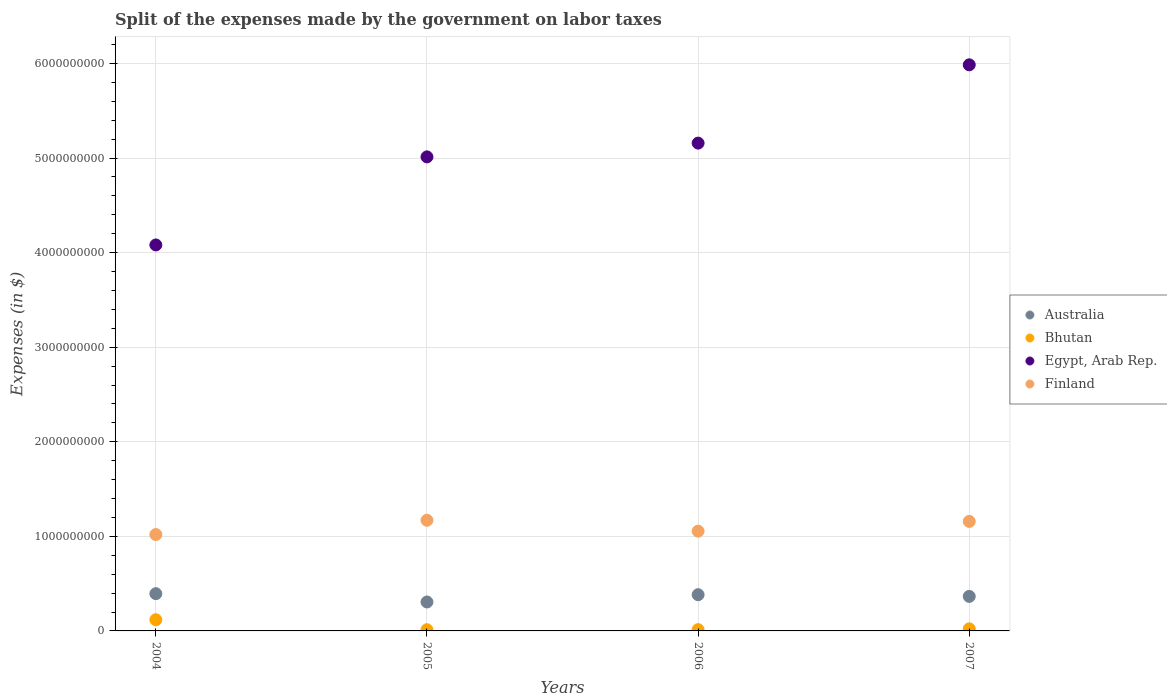What is the expenses made by the government on labor taxes in Finland in 2005?
Offer a very short reply. 1.17e+09. Across all years, what is the maximum expenses made by the government on labor taxes in Australia?
Provide a succinct answer. 3.94e+08. Across all years, what is the minimum expenses made by the government on labor taxes in Finland?
Ensure brevity in your answer.  1.02e+09. What is the total expenses made by the government on labor taxes in Bhutan in the graph?
Keep it short and to the point. 1.66e+08. What is the difference between the expenses made by the government on labor taxes in Bhutan in 2005 and that in 2006?
Make the answer very short. -6.82e+05. What is the difference between the expenses made by the government on labor taxes in Egypt, Arab Rep. in 2004 and the expenses made by the government on labor taxes in Finland in 2005?
Your answer should be compact. 2.91e+09. What is the average expenses made by the government on labor taxes in Egypt, Arab Rep. per year?
Your response must be concise. 5.06e+09. In the year 2007, what is the difference between the expenses made by the government on labor taxes in Bhutan and expenses made by the government on labor taxes in Australia?
Give a very brief answer. -3.43e+08. What is the ratio of the expenses made by the government on labor taxes in Australia in 2004 to that in 2005?
Your response must be concise. 1.29. Is the expenses made by the government on labor taxes in Australia in 2004 less than that in 2005?
Offer a very short reply. No. Is the difference between the expenses made by the government on labor taxes in Bhutan in 2004 and 2007 greater than the difference between the expenses made by the government on labor taxes in Australia in 2004 and 2007?
Your answer should be very brief. Yes. What is the difference between the highest and the lowest expenses made by the government on labor taxes in Australia?
Your answer should be compact. 8.80e+07. In how many years, is the expenses made by the government on labor taxes in Finland greater than the average expenses made by the government on labor taxes in Finland taken over all years?
Your response must be concise. 2. Is it the case that in every year, the sum of the expenses made by the government on labor taxes in Finland and expenses made by the government on labor taxes in Bhutan  is greater than the sum of expenses made by the government on labor taxes in Australia and expenses made by the government on labor taxes in Egypt, Arab Rep.?
Offer a very short reply. Yes. Is the expenses made by the government on labor taxes in Bhutan strictly greater than the expenses made by the government on labor taxes in Australia over the years?
Give a very brief answer. No. Is the expenses made by the government on labor taxes in Australia strictly less than the expenses made by the government on labor taxes in Bhutan over the years?
Your answer should be compact. No. How many years are there in the graph?
Your answer should be very brief. 4. What is the difference between two consecutive major ticks on the Y-axis?
Your response must be concise. 1.00e+09. Are the values on the major ticks of Y-axis written in scientific E-notation?
Make the answer very short. No. Does the graph contain grids?
Your response must be concise. Yes. Where does the legend appear in the graph?
Your response must be concise. Center right. How many legend labels are there?
Your response must be concise. 4. What is the title of the graph?
Offer a terse response. Split of the expenses made by the government on labor taxes. Does "Chile" appear as one of the legend labels in the graph?
Your response must be concise. No. What is the label or title of the Y-axis?
Offer a very short reply. Expenses (in $). What is the Expenses (in $) in Australia in 2004?
Your answer should be very brief. 3.94e+08. What is the Expenses (in $) in Bhutan in 2004?
Provide a short and direct response. 1.18e+08. What is the Expenses (in $) in Egypt, Arab Rep. in 2004?
Your response must be concise. 4.08e+09. What is the Expenses (in $) of Finland in 2004?
Provide a succinct answer. 1.02e+09. What is the Expenses (in $) of Australia in 2005?
Your response must be concise. 3.06e+08. What is the Expenses (in $) of Bhutan in 2005?
Provide a succinct answer. 1.28e+07. What is the Expenses (in $) in Egypt, Arab Rep. in 2005?
Give a very brief answer. 5.01e+09. What is the Expenses (in $) of Finland in 2005?
Ensure brevity in your answer.  1.17e+09. What is the Expenses (in $) of Australia in 2006?
Give a very brief answer. 3.83e+08. What is the Expenses (in $) in Bhutan in 2006?
Provide a succinct answer. 1.35e+07. What is the Expenses (in $) in Egypt, Arab Rep. in 2006?
Make the answer very short. 5.16e+09. What is the Expenses (in $) of Finland in 2006?
Your response must be concise. 1.06e+09. What is the Expenses (in $) in Australia in 2007?
Your answer should be very brief. 3.65e+08. What is the Expenses (in $) of Bhutan in 2007?
Offer a terse response. 2.20e+07. What is the Expenses (in $) in Egypt, Arab Rep. in 2007?
Offer a very short reply. 5.99e+09. What is the Expenses (in $) in Finland in 2007?
Ensure brevity in your answer.  1.16e+09. Across all years, what is the maximum Expenses (in $) in Australia?
Provide a succinct answer. 3.94e+08. Across all years, what is the maximum Expenses (in $) in Bhutan?
Your answer should be compact. 1.18e+08. Across all years, what is the maximum Expenses (in $) in Egypt, Arab Rep.?
Make the answer very short. 5.99e+09. Across all years, what is the maximum Expenses (in $) of Finland?
Your answer should be compact. 1.17e+09. Across all years, what is the minimum Expenses (in $) in Australia?
Keep it short and to the point. 3.06e+08. Across all years, what is the minimum Expenses (in $) of Bhutan?
Give a very brief answer. 1.28e+07. Across all years, what is the minimum Expenses (in $) of Egypt, Arab Rep.?
Provide a short and direct response. 4.08e+09. Across all years, what is the minimum Expenses (in $) of Finland?
Give a very brief answer. 1.02e+09. What is the total Expenses (in $) in Australia in the graph?
Your answer should be very brief. 1.45e+09. What is the total Expenses (in $) of Bhutan in the graph?
Provide a succinct answer. 1.66e+08. What is the total Expenses (in $) of Egypt, Arab Rep. in the graph?
Your response must be concise. 2.02e+1. What is the total Expenses (in $) in Finland in the graph?
Provide a short and direct response. 4.40e+09. What is the difference between the Expenses (in $) in Australia in 2004 and that in 2005?
Provide a succinct answer. 8.80e+07. What is the difference between the Expenses (in $) of Bhutan in 2004 and that in 2005?
Keep it short and to the point. 1.05e+08. What is the difference between the Expenses (in $) in Egypt, Arab Rep. in 2004 and that in 2005?
Ensure brevity in your answer.  -9.31e+08. What is the difference between the Expenses (in $) in Finland in 2004 and that in 2005?
Your response must be concise. -1.51e+08. What is the difference between the Expenses (in $) in Australia in 2004 and that in 2006?
Your response must be concise. 1.10e+07. What is the difference between the Expenses (in $) of Bhutan in 2004 and that in 2006?
Provide a succinct answer. 1.05e+08. What is the difference between the Expenses (in $) of Egypt, Arab Rep. in 2004 and that in 2006?
Your answer should be very brief. -1.08e+09. What is the difference between the Expenses (in $) in Finland in 2004 and that in 2006?
Provide a short and direct response. -3.60e+07. What is the difference between the Expenses (in $) in Australia in 2004 and that in 2007?
Offer a very short reply. 2.90e+07. What is the difference between the Expenses (in $) in Bhutan in 2004 and that in 2007?
Ensure brevity in your answer.  9.61e+07. What is the difference between the Expenses (in $) in Egypt, Arab Rep. in 2004 and that in 2007?
Offer a terse response. -1.90e+09. What is the difference between the Expenses (in $) in Finland in 2004 and that in 2007?
Provide a succinct answer. -1.39e+08. What is the difference between the Expenses (in $) in Australia in 2005 and that in 2006?
Keep it short and to the point. -7.70e+07. What is the difference between the Expenses (in $) of Bhutan in 2005 and that in 2006?
Ensure brevity in your answer.  -6.82e+05. What is the difference between the Expenses (in $) of Egypt, Arab Rep. in 2005 and that in 2006?
Your answer should be compact. -1.46e+08. What is the difference between the Expenses (in $) in Finland in 2005 and that in 2006?
Offer a very short reply. 1.15e+08. What is the difference between the Expenses (in $) of Australia in 2005 and that in 2007?
Provide a succinct answer. -5.90e+07. What is the difference between the Expenses (in $) in Bhutan in 2005 and that in 2007?
Your answer should be very brief. -9.28e+06. What is the difference between the Expenses (in $) of Egypt, Arab Rep. in 2005 and that in 2007?
Offer a terse response. -9.73e+08. What is the difference between the Expenses (in $) in Australia in 2006 and that in 2007?
Offer a terse response. 1.80e+07. What is the difference between the Expenses (in $) of Bhutan in 2006 and that in 2007?
Make the answer very short. -8.59e+06. What is the difference between the Expenses (in $) in Egypt, Arab Rep. in 2006 and that in 2007?
Your answer should be compact. -8.28e+08. What is the difference between the Expenses (in $) in Finland in 2006 and that in 2007?
Your answer should be very brief. -1.03e+08. What is the difference between the Expenses (in $) in Australia in 2004 and the Expenses (in $) in Bhutan in 2005?
Provide a succinct answer. 3.81e+08. What is the difference between the Expenses (in $) of Australia in 2004 and the Expenses (in $) of Egypt, Arab Rep. in 2005?
Give a very brief answer. -4.62e+09. What is the difference between the Expenses (in $) in Australia in 2004 and the Expenses (in $) in Finland in 2005?
Provide a short and direct response. -7.76e+08. What is the difference between the Expenses (in $) of Bhutan in 2004 and the Expenses (in $) of Egypt, Arab Rep. in 2005?
Keep it short and to the point. -4.89e+09. What is the difference between the Expenses (in $) of Bhutan in 2004 and the Expenses (in $) of Finland in 2005?
Provide a succinct answer. -1.05e+09. What is the difference between the Expenses (in $) of Egypt, Arab Rep. in 2004 and the Expenses (in $) of Finland in 2005?
Provide a succinct answer. 2.91e+09. What is the difference between the Expenses (in $) in Australia in 2004 and the Expenses (in $) in Bhutan in 2006?
Ensure brevity in your answer.  3.81e+08. What is the difference between the Expenses (in $) of Australia in 2004 and the Expenses (in $) of Egypt, Arab Rep. in 2006?
Make the answer very short. -4.76e+09. What is the difference between the Expenses (in $) in Australia in 2004 and the Expenses (in $) in Finland in 2006?
Provide a succinct answer. -6.61e+08. What is the difference between the Expenses (in $) of Bhutan in 2004 and the Expenses (in $) of Egypt, Arab Rep. in 2006?
Ensure brevity in your answer.  -5.04e+09. What is the difference between the Expenses (in $) of Bhutan in 2004 and the Expenses (in $) of Finland in 2006?
Provide a succinct answer. -9.37e+08. What is the difference between the Expenses (in $) of Egypt, Arab Rep. in 2004 and the Expenses (in $) of Finland in 2006?
Ensure brevity in your answer.  3.03e+09. What is the difference between the Expenses (in $) of Australia in 2004 and the Expenses (in $) of Bhutan in 2007?
Make the answer very short. 3.72e+08. What is the difference between the Expenses (in $) in Australia in 2004 and the Expenses (in $) in Egypt, Arab Rep. in 2007?
Provide a short and direct response. -5.59e+09. What is the difference between the Expenses (in $) in Australia in 2004 and the Expenses (in $) in Finland in 2007?
Your answer should be very brief. -7.64e+08. What is the difference between the Expenses (in $) of Bhutan in 2004 and the Expenses (in $) of Egypt, Arab Rep. in 2007?
Make the answer very short. -5.87e+09. What is the difference between the Expenses (in $) of Bhutan in 2004 and the Expenses (in $) of Finland in 2007?
Give a very brief answer. -1.04e+09. What is the difference between the Expenses (in $) in Egypt, Arab Rep. in 2004 and the Expenses (in $) in Finland in 2007?
Ensure brevity in your answer.  2.92e+09. What is the difference between the Expenses (in $) in Australia in 2005 and the Expenses (in $) in Bhutan in 2006?
Provide a succinct answer. 2.93e+08. What is the difference between the Expenses (in $) of Australia in 2005 and the Expenses (in $) of Egypt, Arab Rep. in 2006?
Provide a succinct answer. -4.85e+09. What is the difference between the Expenses (in $) in Australia in 2005 and the Expenses (in $) in Finland in 2006?
Ensure brevity in your answer.  -7.49e+08. What is the difference between the Expenses (in $) of Bhutan in 2005 and the Expenses (in $) of Egypt, Arab Rep. in 2006?
Offer a terse response. -5.15e+09. What is the difference between the Expenses (in $) in Bhutan in 2005 and the Expenses (in $) in Finland in 2006?
Offer a very short reply. -1.04e+09. What is the difference between the Expenses (in $) of Egypt, Arab Rep. in 2005 and the Expenses (in $) of Finland in 2006?
Provide a succinct answer. 3.96e+09. What is the difference between the Expenses (in $) of Australia in 2005 and the Expenses (in $) of Bhutan in 2007?
Provide a succinct answer. 2.84e+08. What is the difference between the Expenses (in $) in Australia in 2005 and the Expenses (in $) in Egypt, Arab Rep. in 2007?
Ensure brevity in your answer.  -5.68e+09. What is the difference between the Expenses (in $) in Australia in 2005 and the Expenses (in $) in Finland in 2007?
Offer a very short reply. -8.52e+08. What is the difference between the Expenses (in $) in Bhutan in 2005 and the Expenses (in $) in Egypt, Arab Rep. in 2007?
Offer a very short reply. -5.97e+09. What is the difference between the Expenses (in $) in Bhutan in 2005 and the Expenses (in $) in Finland in 2007?
Keep it short and to the point. -1.15e+09. What is the difference between the Expenses (in $) in Egypt, Arab Rep. in 2005 and the Expenses (in $) in Finland in 2007?
Your answer should be compact. 3.85e+09. What is the difference between the Expenses (in $) of Australia in 2006 and the Expenses (in $) of Bhutan in 2007?
Ensure brevity in your answer.  3.61e+08. What is the difference between the Expenses (in $) in Australia in 2006 and the Expenses (in $) in Egypt, Arab Rep. in 2007?
Offer a terse response. -5.60e+09. What is the difference between the Expenses (in $) of Australia in 2006 and the Expenses (in $) of Finland in 2007?
Ensure brevity in your answer.  -7.75e+08. What is the difference between the Expenses (in $) of Bhutan in 2006 and the Expenses (in $) of Egypt, Arab Rep. in 2007?
Offer a very short reply. -5.97e+09. What is the difference between the Expenses (in $) of Bhutan in 2006 and the Expenses (in $) of Finland in 2007?
Make the answer very short. -1.14e+09. What is the difference between the Expenses (in $) of Egypt, Arab Rep. in 2006 and the Expenses (in $) of Finland in 2007?
Offer a very short reply. 4.00e+09. What is the average Expenses (in $) in Australia per year?
Give a very brief answer. 3.62e+08. What is the average Expenses (in $) in Bhutan per year?
Provide a short and direct response. 4.16e+07. What is the average Expenses (in $) of Egypt, Arab Rep. per year?
Make the answer very short. 5.06e+09. What is the average Expenses (in $) of Finland per year?
Make the answer very short. 1.10e+09. In the year 2004, what is the difference between the Expenses (in $) of Australia and Expenses (in $) of Bhutan?
Make the answer very short. 2.76e+08. In the year 2004, what is the difference between the Expenses (in $) in Australia and Expenses (in $) in Egypt, Arab Rep.?
Offer a terse response. -3.69e+09. In the year 2004, what is the difference between the Expenses (in $) in Australia and Expenses (in $) in Finland?
Give a very brief answer. -6.25e+08. In the year 2004, what is the difference between the Expenses (in $) of Bhutan and Expenses (in $) of Egypt, Arab Rep.?
Give a very brief answer. -3.96e+09. In the year 2004, what is the difference between the Expenses (in $) of Bhutan and Expenses (in $) of Finland?
Offer a very short reply. -9.01e+08. In the year 2004, what is the difference between the Expenses (in $) of Egypt, Arab Rep. and Expenses (in $) of Finland?
Your answer should be very brief. 3.06e+09. In the year 2005, what is the difference between the Expenses (in $) of Australia and Expenses (in $) of Bhutan?
Keep it short and to the point. 2.93e+08. In the year 2005, what is the difference between the Expenses (in $) in Australia and Expenses (in $) in Egypt, Arab Rep.?
Make the answer very short. -4.71e+09. In the year 2005, what is the difference between the Expenses (in $) in Australia and Expenses (in $) in Finland?
Your answer should be compact. -8.64e+08. In the year 2005, what is the difference between the Expenses (in $) of Bhutan and Expenses (in $) of Egypt, Arab Rep.?
Keep it short and to the point. -5.00e+09. In the year 2005, what is the difference between the Expenses (in $) of Bhutan and Expenses (in $) of Finland?
Offer a very short reply. -1.16e+09. In the year 2005, what is the difference between the Expenses (in $) of Egypt, Arab Rep. and Expenses (in $) of Finland?
Keep it short and to the point. 3.84e+09. In the year 2006, what is the difference between the Expenses (in $) of Australia and Expenses (in $) of Bhutan?
Offer a terse response. 3.70e+08. In the year 2006, what is the difference between the Expenses (in $) of Australia and Expenses (in $) of Egypt, Arab Rep.?
Ensure brevity in your answer.  -4.77e+09. In the year 2006, what is the difference between the Expenses (in $) in Australia and Expenses (in $) in Finland?
Provide a succinct answer. -6.72e+08. In the year 2006, what is the difference between the Expenses (in $) in Bhutan and Expenses (in $) in Egypt, Arab Rep.?
Your answer should be compact. -5.14e+09. In the year 2006, what is the difference between the Expenses (in $) of Bhutan and Expenses (in $) of Finland?
Offer a very short reply. -1.04e+09. In the year 2006, what is the difference between the Expenses (in $) of Egypt, Arab Rep. and Expenses (in $) of Finland?
Your answer should be very brief. 4.10e+09. In the year 2007, what is the difference between the Expenses (in $) in Australia and Expenses (in $) in Bhutan?
Make the answer very short. 3.43e+08. In the year 2007, what is the difference between the Expenses (in $) in Australia and Expenses (in $) in Egypt, Arab Rep.?
Offer a very short reply. -5.62e+09. In the year 2007, what is the difference between the Expenses (in $) in Australia and Expenses (in $) in Finland?
Your response must be concise. -7.93e+08. In the year 2007, what is the difference between the Expenses (in $) in Bhutan and Expenses (in $) in Egypt, Arab Rep.?
Give a very brief answer. -5.96e+09. In the year 2007, what is the difference between the Expenses (in $) of Bhutan and Expenses (in $) of Finland?
Offer a very short reply. -1.14e+09. In the year 2007, what is the difference between the Expenses (in $) of Egypt, Arab Rep. and Expenses (in $) of Finland?
Provide a short and direct response. 4.83e+09. What is the ratio of the Expenses (in $) in Australia in 2004 to that in 2005?
Your answer should be compact. 1.29. What is the ratio of the Expenses (in $) of Bhutan in 2004 to that in 2005?
Your answer should be very brief. 9.25. What is the ratio of the Expenses (in $) of Egypt, Arab Rep. in 2004 to that in 2005?
Ensure brevity in your answer.  0.81. What is the ratio of the Expenses (in $) of Finland in 2004 to that in 2005?
Your answer should be very brief. 0.87. What is the ratio of the Expenses (in $) of Australia in 2004 to that in 2006?
Provide a succinct answer. 1.03. What is the ratio of the Expenses (in $) in Bhutan in 2004 to that in 2006?
Make the answer very short. 8.78. What is the ratio of the Expenses (in $) of Egypt, Arab Rep. in 2004 to that in 2006?
Give a very brief answer. 0.79. What is the ratio of the Expenses (in $) in Finland in 2004 to that in 2006?
Your answer should be compact. 0.97. What is the ratio of the Expenses (in $) of Australia in 2004 to that in 2007?
Your response must be concise. 1.08. What is the ratio of the Expenses (in $) in Bhutan in 2004 to that in 2007?
Give a very brief answer. 5.36. What is the ratio of the Expenses (in $) of Egypt, Arab Rep. in 2004 to that in 2007?
Keep it short and to the point. 0.68. What is the ratio of the Expenses (in $) of Australia in 2005 to that in 2006?
Ensure brevity in your answer.  0.8. What is the ratio of the Expenses (in $) of Bhutan in 2005 to that in 2006?
Your answer should be very brief. 0.95. What is the ratio of the Expenses (in $) of Egypt, Arab Rep. in 2005 to that in 2006?
Offer a very short reply. 0.97. What is the ratio of the Expenses (in $) of Finland in 2005 to that in 2006?
Your answer should be compact. 1.11. What is the ratio of the Expenses (in $) of Australia in 2005 to that in 2007?
Offer a terse response. 0.84. What is the ratio of the Expenses (in $) in Bhutan in 2005 to that in 2007?
Provide a short and direct response. 0.58. What is the ratio of the Expenses (in $) in Egypt, Arab Rep. in 2005 to that in 2007?
Your response must be concise. 0.84. What is the ratio of the Expenses (in $) of Finland in 2005 to that in 2007?
Make the answer very short. 1.01. What is the ratio of the Expenses (in $) of Australia in 2006 to that in 2007?
Keep it short and to the point. 1.05. What is the ratio of the Expenses (in $) in Bhutan in 2006 to that in 2007?
Your answer should be very brief. 0.61. What is the ratio of the Expenses (in $) in Egypt, Arab Rep. in 2006 to that in 2007?
Your answer should be compact. 0.86. What is the ratio of the Expenses (in $) in Finland in 2006 to that in 2007?
Ensure brevity in your answer.  0.91. What is the difference between the highest and the second highest Expenses (in $) of Australia?
Provide a succinct answer. 1.10e+07. What is the difference between the highest and the second highest Expenses (in $) of Bhutan?
Provide a short and direct response. 9.61e+07. What is the difference between the highest and the second highest Expenses (in $) in Egypt, Arab Rep.?
Your answer should be very brief. 8.28e+08. What is the difference between the highest and the lowest Expenses (in $) of Australia?
Your response must be concise. 8.80e+07. What is the difference between the highest and the lowest Expenses (in $) of Bhutan?
Your answer should be compact. 1.05e+08. What is the difference between the highest and the lowest Expenses (in $) in Egypt, Arab Rep.?
Your response must be concise. 1.90e+09. What is the difference between the highest and the lowest Expenses (in $) in Finland?
Ensure brevity in your answer.  1.51e+08. 